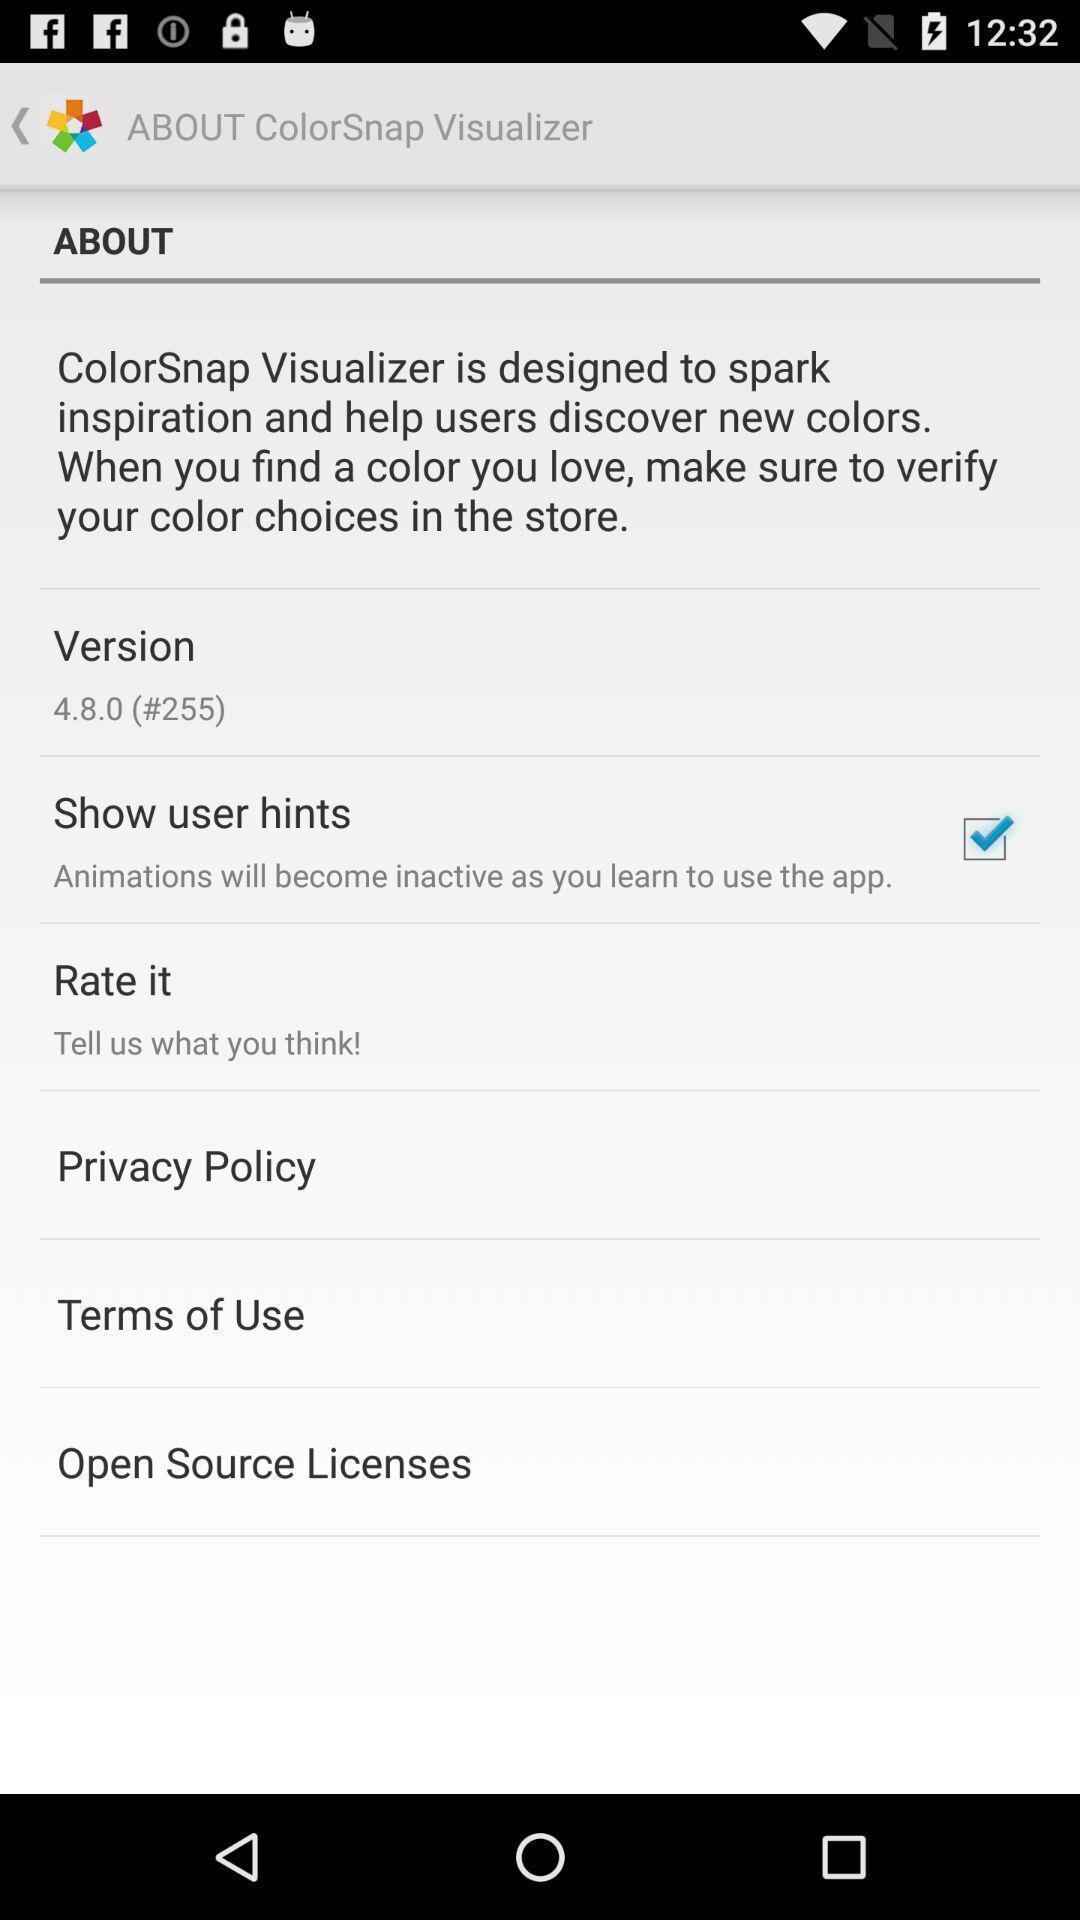Explain what's happening in this screen capture. Various types of descriptions in the about tab. 